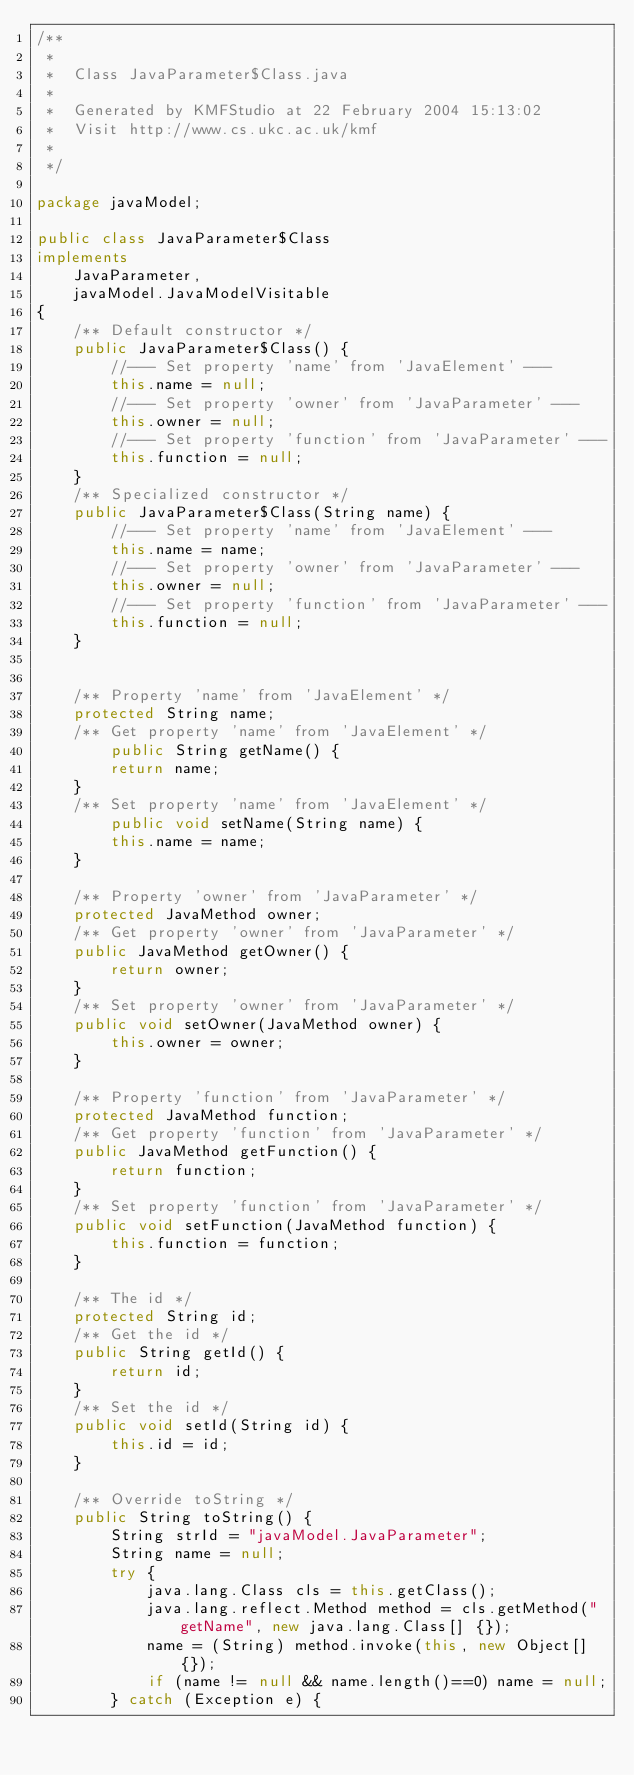Convert code to text. <code><loc_0><loc_0><loc_500><loc_500><_Java_>/**
 *
 *  Class JavaParameter$Class.java
 *
 *  Generated by KMFStudio at 22 February 2004 15:13:02
 *  Visit http://www.cs.ukc.ac.uk/kmf
 *
 */

package javaModel;

public class JavaParameter$Class
implements
	JavaParameter,
    javaModel.JavaModelVisitable
{
	/** Default constructor */
	public JavaParameter$Class() {
		//--- Set property 'name' from 'JavaElement' ---
		this.name = null;
		//--- Set property 'owner' from 'JavaParameter' ---
		this.owner = null;
		//--- Set property 'function' from 'JavaParameter' ---
		this.function = null;
	}
	/** Specialized constructor */
	public JavaParameter$Class(String name) {
		//--- Set property 'name' from 'JavaElement' ---
		this.name = name;
		//--- Set property 'owner' from 'JavaParameter' ---
		this.owner = null;
		//--- Set property 'function' from 'JavaParameter' ---
		this.function = null;
	}


	/** Property 'name' from 'JavaElement' */
	protected String name;
	/** Get property 'name' from 'JavaElement' */
		public String getName() {
		return name;
	}
	/** Set property 'name' from 'JavaElement' */
		public void setName(String name) {
		this.name = name;
	}

	/** Property 'owner' from 'JavaParameter' */
	protected JavaMethod owner;
	/** Get property 'owner' from 'JavaParameter' */
	public JavaMethod getOwner() {
		return owner;
	}
	/** Set property 'owner' from 'JavaParameter' */
	public void setOwner(JavaMethod owner) { 
		this.owner = owner;
	}

	/** Property 'function' from 'JavaParameter' */
	protected JavaMethod function;
	/** Get property 'function' from 'JavaParameter' */
	public JavaMethod getFunction() {
		return function;
	}
	/** Set property 'function' from 'JavaParameter' */
	public void setFunction(JavaMethod function) { 
		this.function = function;
	}

	/** The id */
	protected String id;
	/** Get the id */
	public String getId() {
		return id;
	}
	/** Set the id */
	public void setId(String id) {
		this.id = id;
	}

	/** Override toString */
	public String toString() {
		String strId = "javaModel.JavaParameter";
		String name = null;
		try {
			java.lang.Class cls = this.getClass();
			java.lang.reflect.Method method = cls.getMethod("getName", new java.lang.Class[] {});
			name = (String) method.invoke(this, new Object[] {});
			if (name != null && name.length()==0) name = null;
		} catch (Exception e) {</code> 